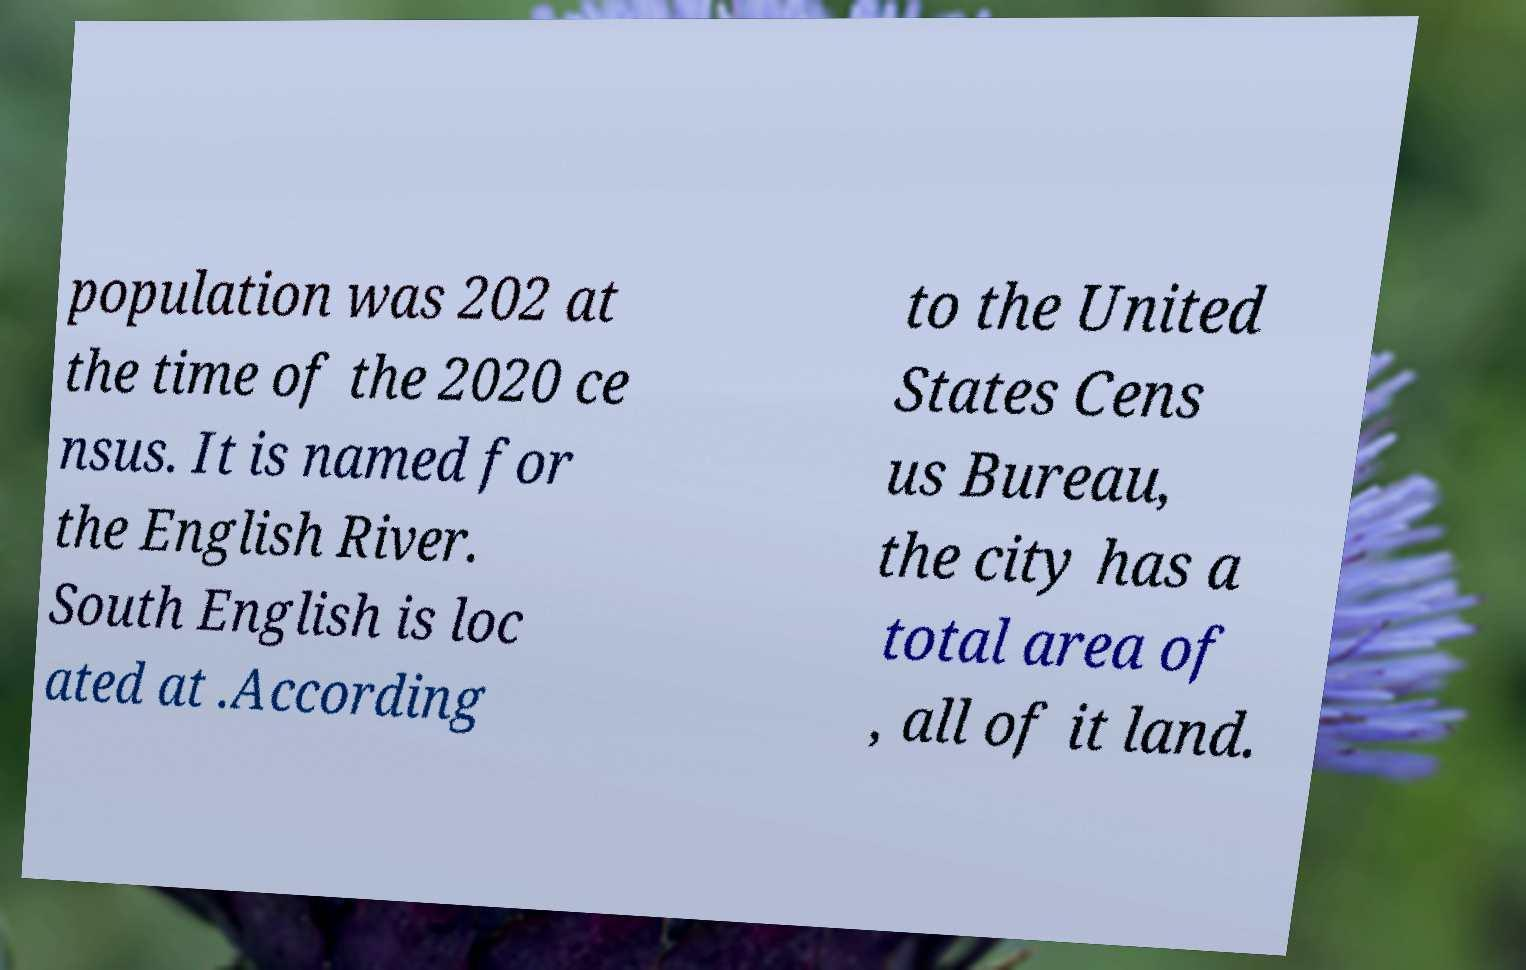There's text embedded in this image that I need extracted. Can you transcribe it verbatim? population was 202 at the time of the 2020 ce nsus. It is named for the English River. South English is loc ated at .According to the United States Cens us Bureau, the city has a total area of , all of it land. 